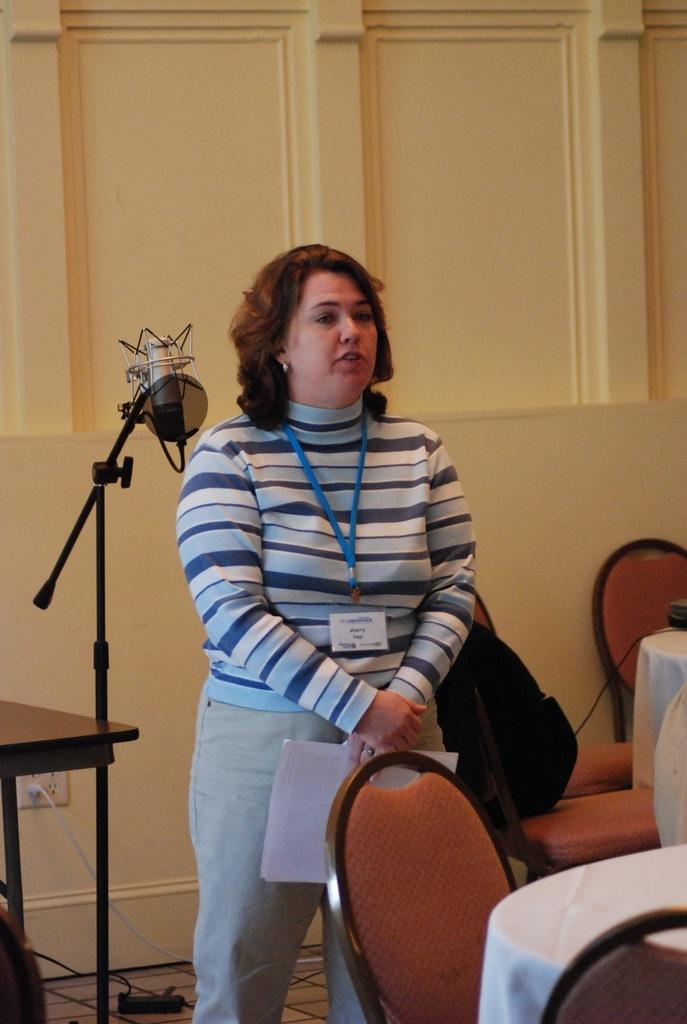What is the woman in the image doing? The woman is standing in the image. Where is the woman standing? The woman is standing on the floor. What is the woman wearing that identifies her? The woman is wearing an ID card. What is the woman holding in her hand? The woman is holding papers in her hand. What furniture is present in the image? There is a chair and a table in the image. What type of wood is the woman's toes made of in the image? The image does not show the woman's toes, and there is no mention of wood in the image. 